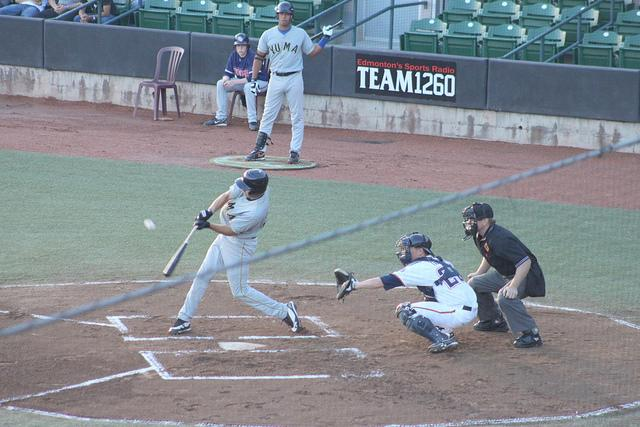What province is this located? Please explain your reasoning. alberta. The sign says the city edmonton, which is located in the province of alberta. 